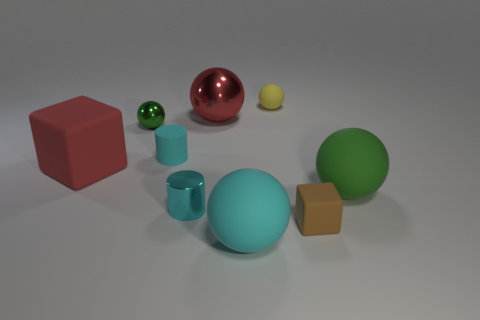Do the large rubber block and the big sphere behind the big green matte ball have the same color?
Make the answer very short. Yes. What number of other tiny cylinders are the same color as the metal cylinder?
Keep it short and to the point. 1. What number of other things are there of the same material as the large red sphere
Provide a succinct answer. 2. Is the number of small cylinders behind the cyan metallic cylinder greater than the number of tiny brown rubber blocks behind the small green thing?
Offer a very short reply. Yes. What is the material of the green thing on the left side of the brown object?
Your answer should be very brief. Metal. Is the tiny green shiny object the same shape as the large cyan rubber thing?
Your response must be concise. Yes. Is there anything else that has the same color as the tiny matte cylinder?
Your response must be concise. Yes. There is another large matte object that is the same shape as the big cyan matte object; what color is it?
Provide a short and direct response. Green. Are there more tiny brown matte blocks that are in front of the large green matte thing than large blue rubber cylinders?
Give a very brief answer. Yes. There is a big sphere that is in front of the large green matte object; what is its color?
Your answer should be compact. Cyan. 